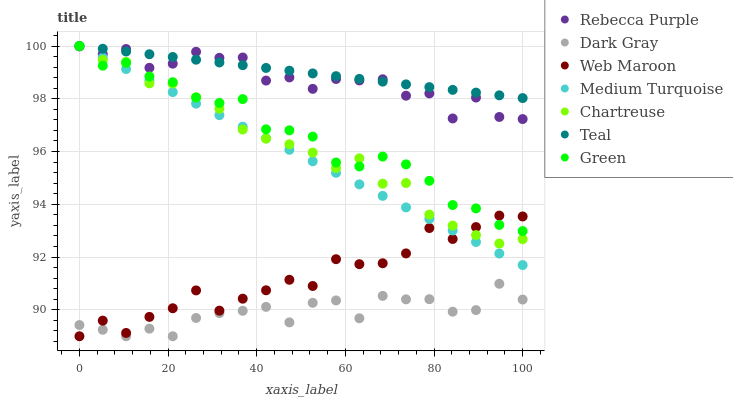Does Dark Gray have the minimum area under the curve?
Answer yes or no. Yes. Does Teal have the maximum area under the curve?
Answer yes or no. Yes. Does Web Maroon have the minimum area under the curve?
Answer yes or no. No. Does Web Maroon have the maximum area under the curve?
Answer yes or no. No. Is Medium Turquoise the smoothest?
Answer yes or no. Yes. Is Rebecca Purple the roughest?
Answer yes or no. Yes. Is Web Maroon the smoothest?
Answer yes or no. No. Is Web Maroon the roughest?
Answer yes or no. No. Does Web Maroon have the lowest value?
Answer yes or no. Yes. Does Chartreuse have the lowest value?
Answer yes or no. No. Does Teal have the highest value?
Answer yes or no. Yes. Does Web Maroon have the highest value?
Answer yes or no. No. Is Web Maroon less than Rebecca Purple?
Answer yes or no. Yes. Is Teal greater than Dark Gray?
Answer yes or no. Yes. Does Dark Gray intersect Web Maroon?
Answer yes or no. Yes. Is Dark Gray less than Web Maroon?
Answer yes or no. No. Is Dark Gray greater than Web Maroon?
Answer yes or no. No. Does Web Maroon intersect Rebecca Purple?
Answer yes or no. No. 